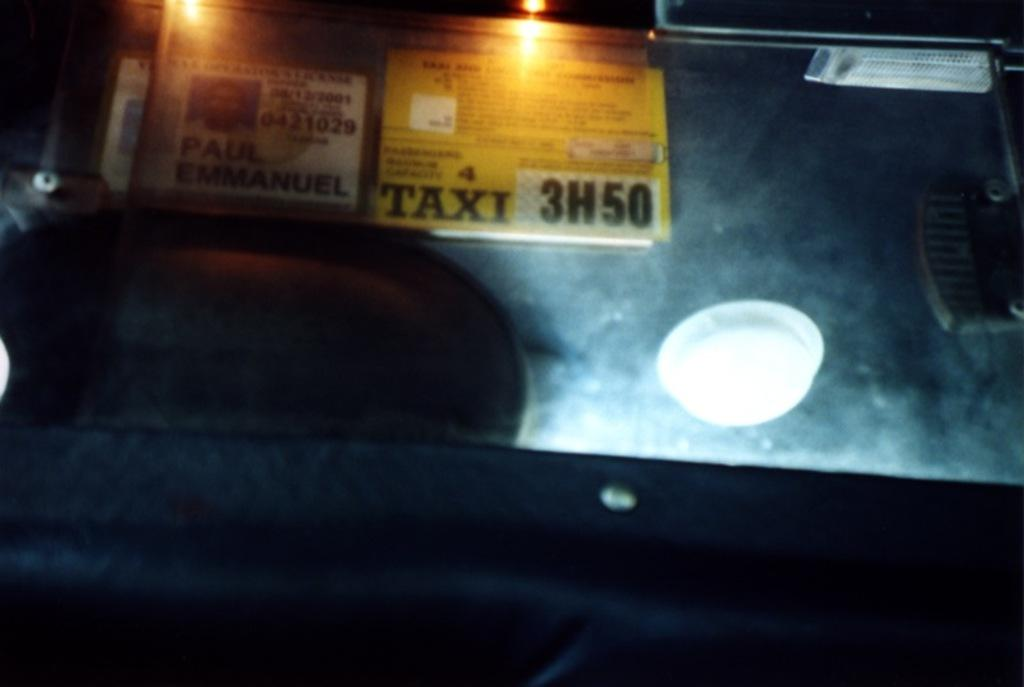What is the main subject of the image? The main subject of the image is a card with text and a person's picture. Can you describe any other elements in the image? Yes, there is a light in the image, as well as other objects. What type of square can be seen on the card in the image? There is no square present on the card in the image; it features text and a person's picture. 